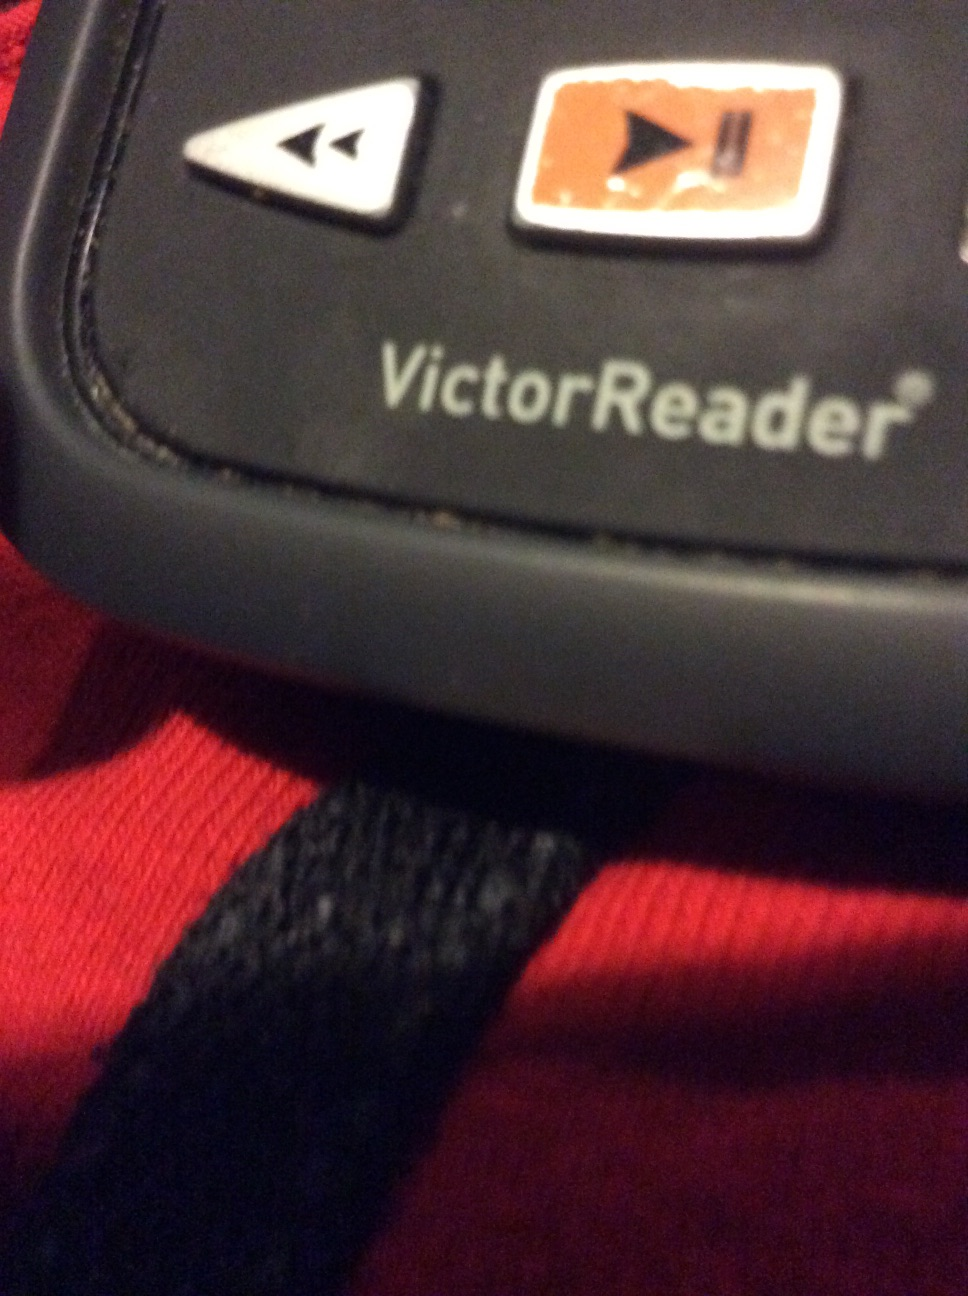Can you describe what this device does? The VictorReader is a specialized device primarily used by visually impaired individuals. It reads aloud text from books, documents, and other sources, allowing users to absorb written information audibly. It includes physical buttons for easy navigation through content, such as play, pause, forward, and backward. 